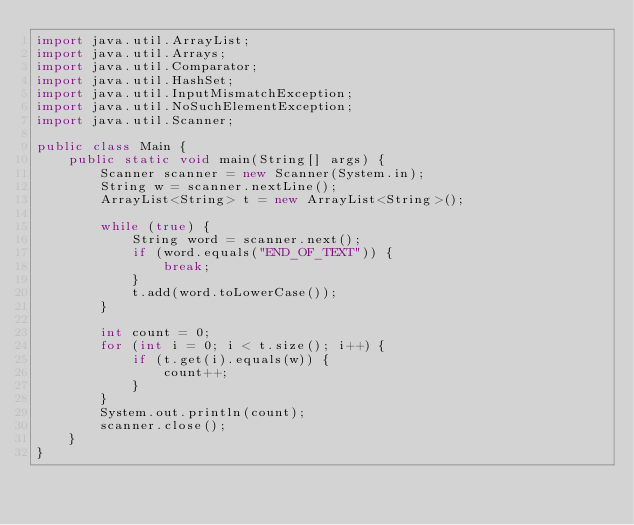Convert code to text. <code><loc_0><loc_0><loc_500><loc_500><_Java_>import java.util.ArrayList;
import java.util.Arrays;
import java.util.Comparator;
import java.util.HashSet;
import java.util.InputMismatchException;
import java.util.NoSuchElementException;
import java.util.Scanner;

public class Main {
    public static void main(String[] args) {
        Scanner scanner = new Scanner(System.in);
        String w = scanner.nextLine();
        ArrayList<String> t = new ArrayList<String>();

        while (true) {
            String word = scanner.next();
            if (word.equals("END_OF_TEXT")) {
                break;
            }
            t.add(word.toLowerCase());
        }

        int count = 0;
        for (int i = 0; i < t.size(); i++) {
            if (t.get(i).equals(w)) {
                count++;
            }
        }
        System.out.println(count);
        scanner.close();
    }
}

</code> 